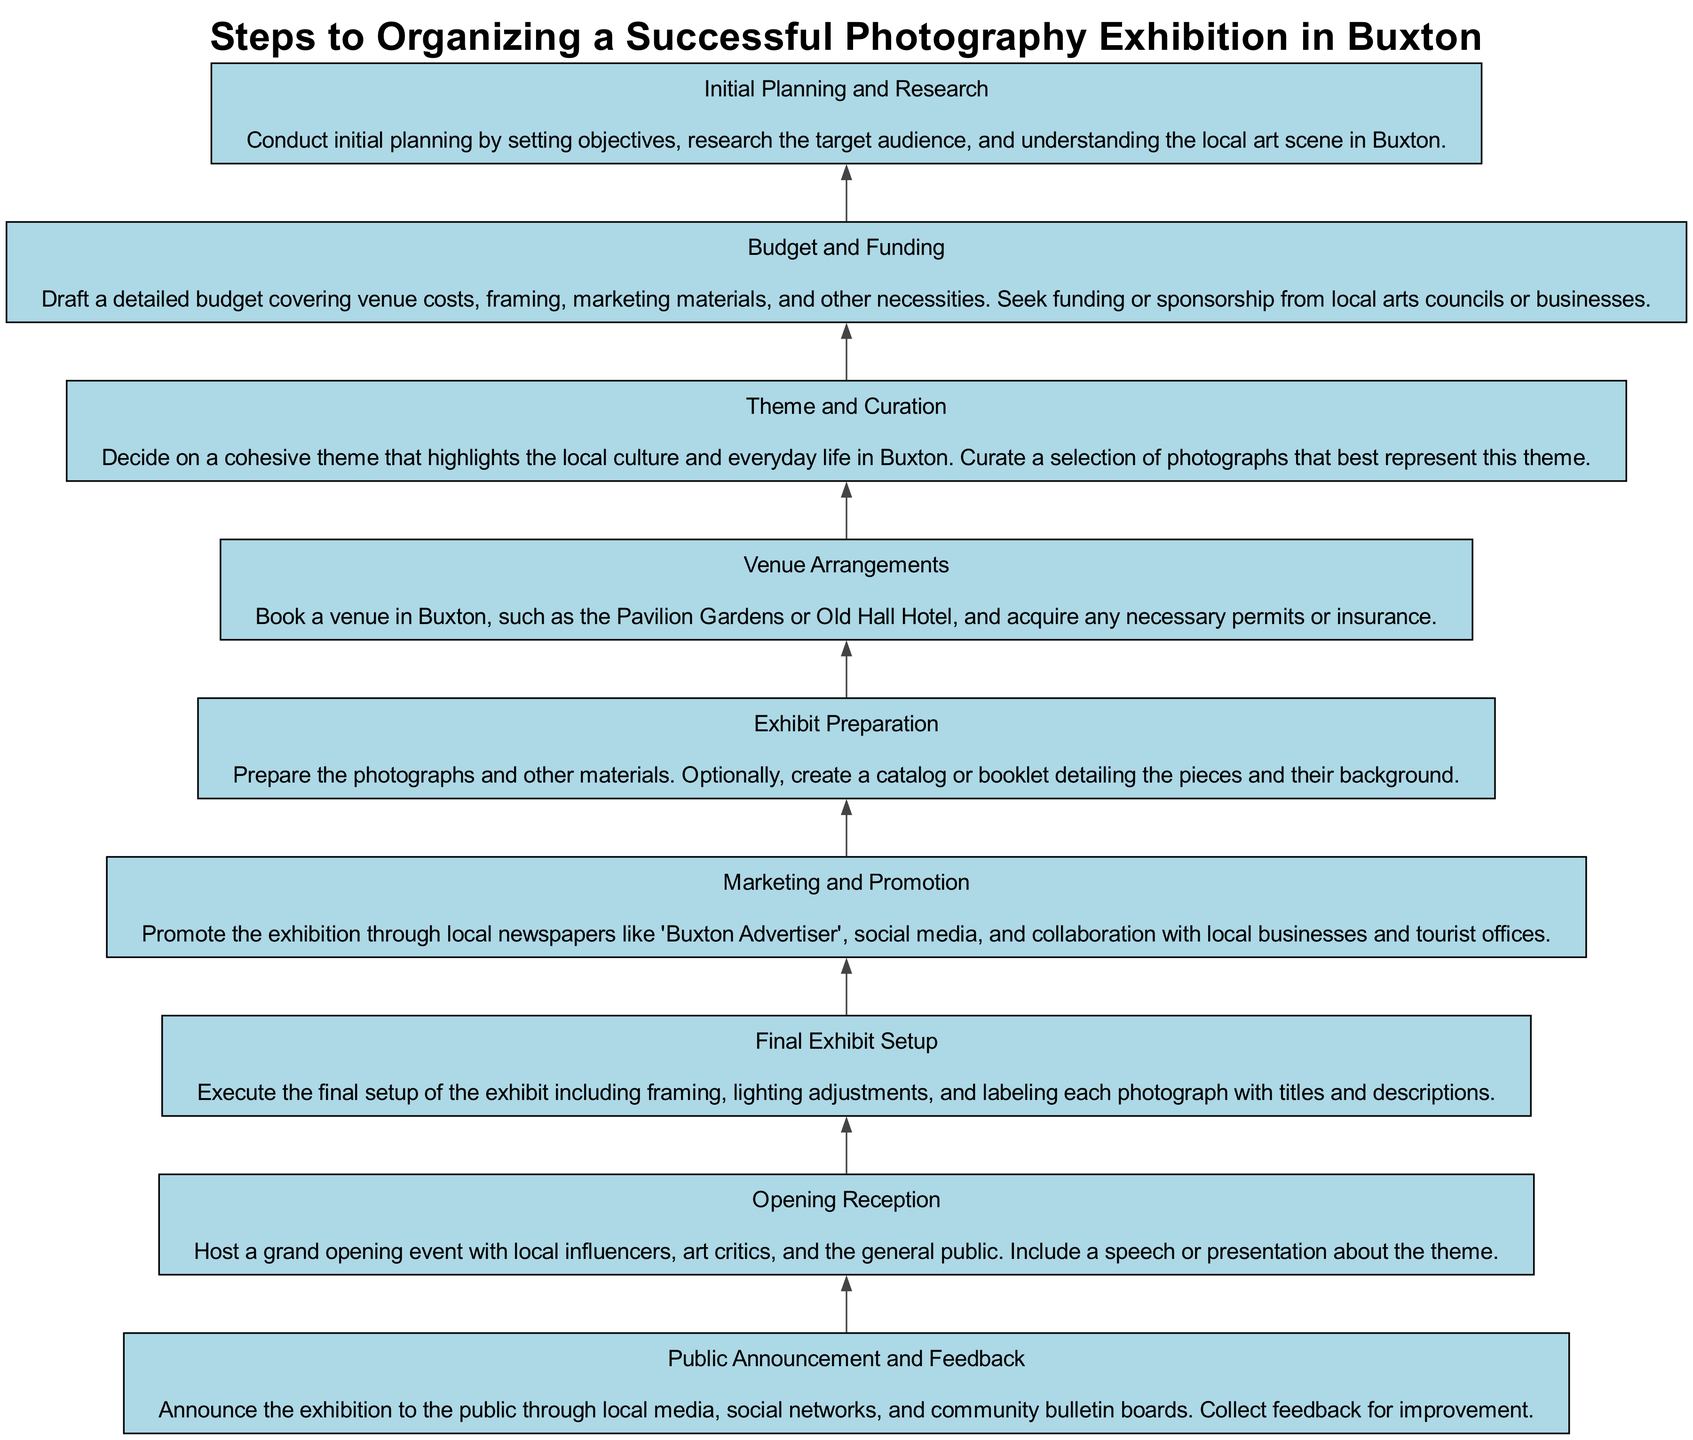What is the first step in organizing the exhibition? The first step listed in the flow chart is "Initial Planning and Research". This step is at the bottom of the diagram, indicating it is the starting point of the process.
Answer: Initial Planning and Research How many steps are there in total? There are 9 steps outlined in the flow chart, which can be counted as each node represents a distinct step in the process.
Answer: 9 What does the final step involve? The final step in the flow chart is "Opening Reception", which involves hosting a grand opening event with local influencers, art critics, and the public.
Answer: Opening Reception Which step comes directly before "Venue Arrangements"? "Budget and Funding" comes directly before "Venue Arrangements" in the flow of the diagram, indicating it is the preceding step in the process.
Answer: Budget and Funding Which node indicates the step that requires actual preparation of photographs? The node for "Exhibit Preparation" indicates the step that requires preparing the photographs and other materials for the exhibition.
Answer: Exhibit Preparation What is the relationship between "Theme and Curation" and "Final Exhibit Setup"? "Theme and Curation" is a preceding step to "Final Exhibit Setup", which means the theme needs to be decided before the actual setup of the exhibition can take place.
Answer: Preceding How is the flow of this diagram structured? The flow is structured from bottom to top, indicating that each step should be completed sequentially, starting from initial planning and finishing with the opening reception.
Answer: Bottom to top What is included in "Marketing and Promotion"? "Marketing and Promotion" includes promoting the exhibition through local newspapers, social media, and partnerships with local businesses and tourist offices.
Answer: Local newspapers and social media What does the "Public Announcement and Feedback" step focus on? This step focuses on announcing the exhibition to the public through various channels and collecting feedback for further improvement, indicating a community engagement approach.
Answer: Community engagement 